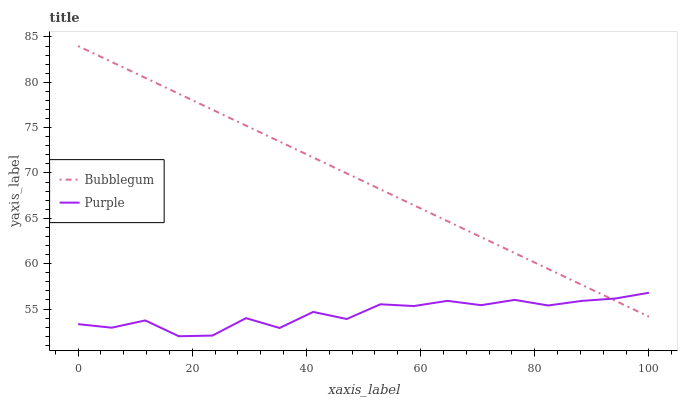Does Purple have the minimum area under the curve?
Answer yes or no. Yes. Does Bubblegum have the maximum area under the curve?
Answer yes or no. Yes. Does Bubblegum have the minimum area under the curve?
Answer yes or no. No. Is Bubblegum the smoothest?
Answer yes or no. Yes. Is Purple the roughest?
Answer yes or no. Yes. Is Bubblegum the roughest?
Answer yes or no. No. Does Purple have the lowest value?
Answer yes or no. Yes. Does Bubblegum have the lowest value?
Answer yes or no. No. Does Bubblegum have the highest value?
Answer yes or no. Yes. Does Bubblegum intersect Purple?
Answer yes or no. Yes. Is Bubblegum less than Purple?
Answer yes or no. No. Is Bubblegum greater than Purple?
Answer yes or no. No. 